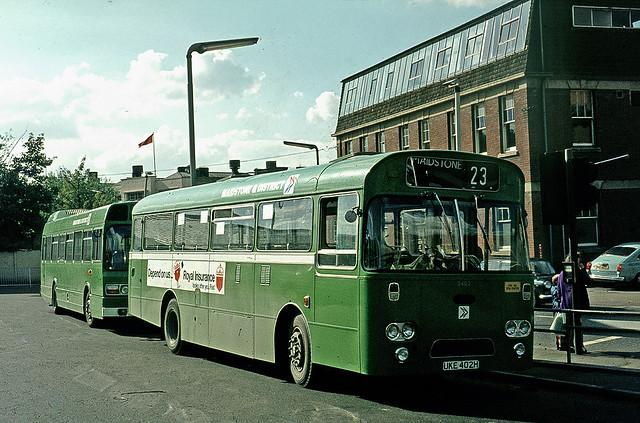What is the sum of each individual digit on the top of the bus?

Choices:
A) 23
B) five
C) 223
D) 32 five 